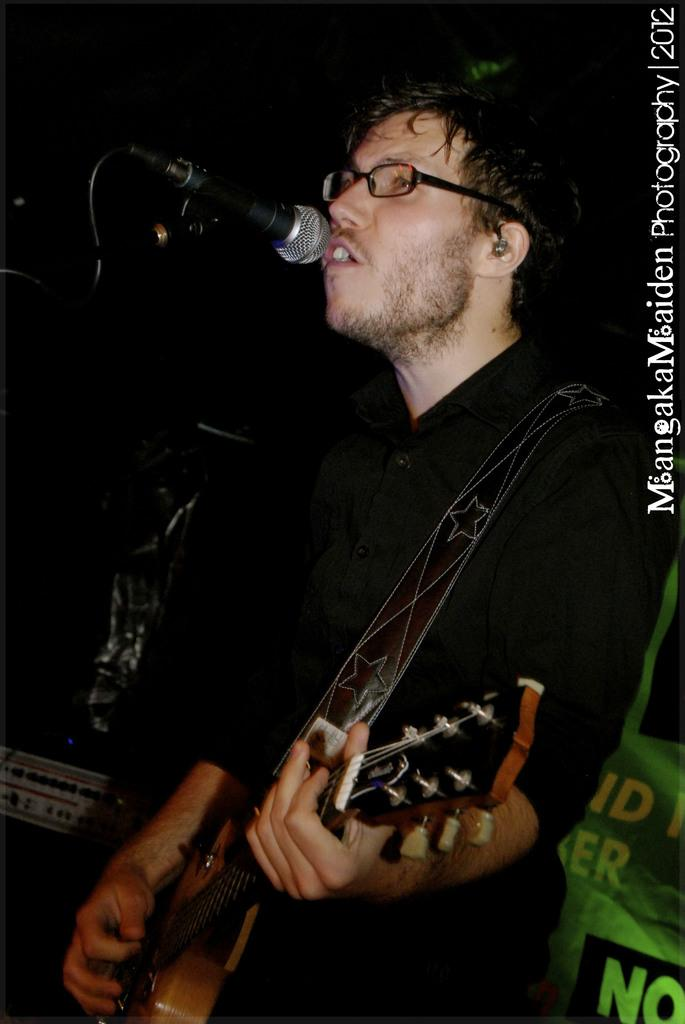What is the man in the image doing? The man is singing a song and playing a guitar. What is the man holding in the image? The man is holding a microphone. What can be seen in the background of the image? The background of the image is black in color. How many bones can be seen in the image? There are no bones visible in the image; it features a man singing and playing a guitar with a black background. 